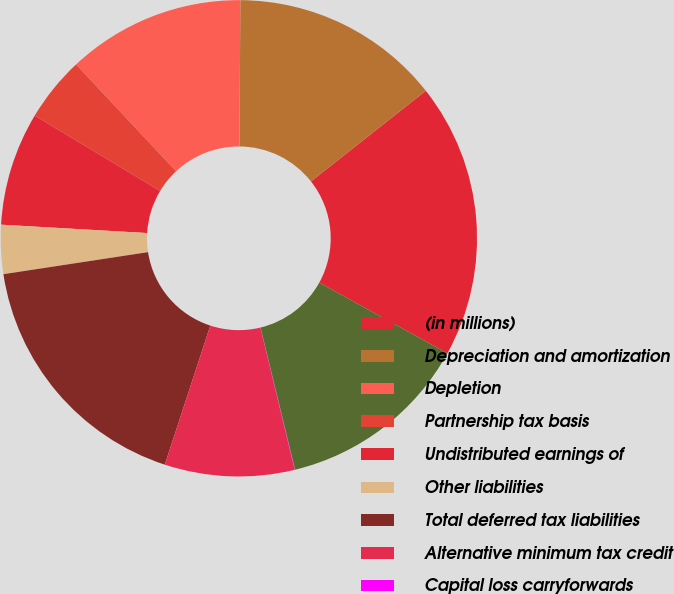Convert chart to OTSL. <chart><loc_0><loc_0><loc_500><loc_500><pie_chart><fcel>(in millions)<fcel>Depreciation and amortization<fcel>Depletion<fcel>Partnership tax basis<fcel>Undistributed earnings of<fcel>Other liabilities<fcel>Total deferred tax liabilities<fcel>Alternative minimum tax credit<fcel>Capital loss carryforwards<fcel>Foreign tax credit<nl><fcel>18.65%<fcel>14.27%<fcel>12.08%<fcel>4.41%<fcel>7.7%<fcel>3.32%<fcel>17.56%<fcel>8.8%<fcel>0.03%<fcel>13.18%<nl></chart> 